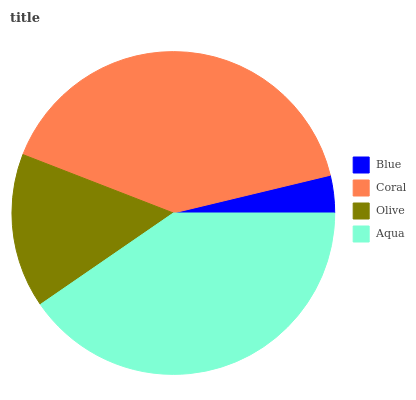Is Blue the minimum?
Answer yes or no. Yes. Is Aqua the maximum?
Answer yes or no. Yes. Is Coral the minimum?
Answer yes or no. No. Is Coral the maximum?
Answer yes or no. No. Is Coral greater than Blue?
Answer yes or no. Yes. Is Blue less than Coral?
Answer yes or no. Yes. Is Blue greater than Coral?
Answer yes or no. No. Is Coral less than Blue?
Answer yes or no. No. Is Coral the high median?
Answer yes or no. Yes. Is Olive the low median?
Answer yes or no. Yes. Is Aqua the high median?
Answer yes or no. No. Is Blue the low median?
Answer yes or no. No. 